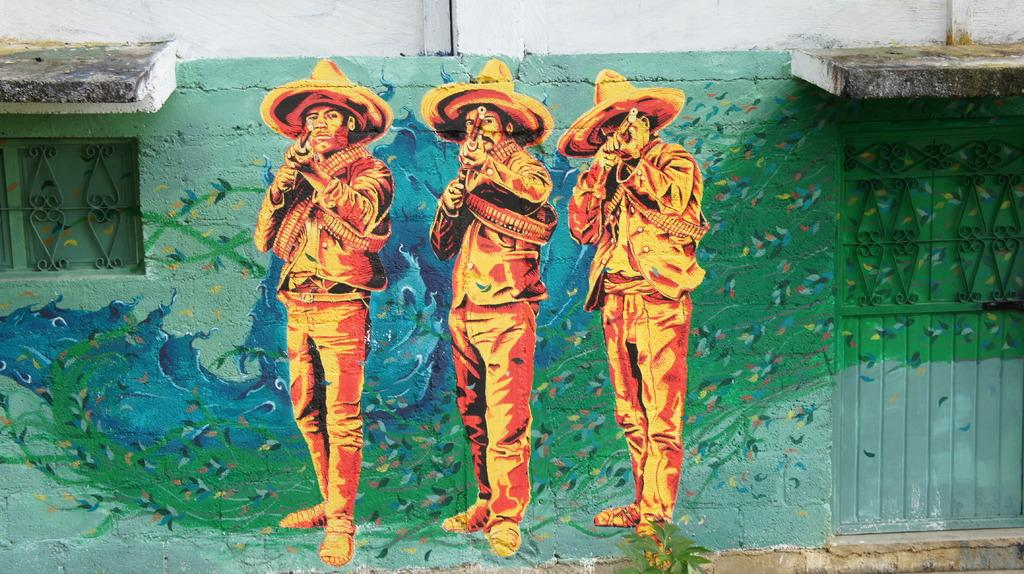What is hanging on the wall in the image? There is a painting on the wall in the image. What architectural feature can be seen on the right side of the image? There is a door on the right side of the image. What allows natural light to enter the room in the image? There is a window on the left side of the image. Where is the sofa located in the image? There is no sofa present in the image. What type of yam is being cooked in the image? There is no yam or cooking activity present in the image. 